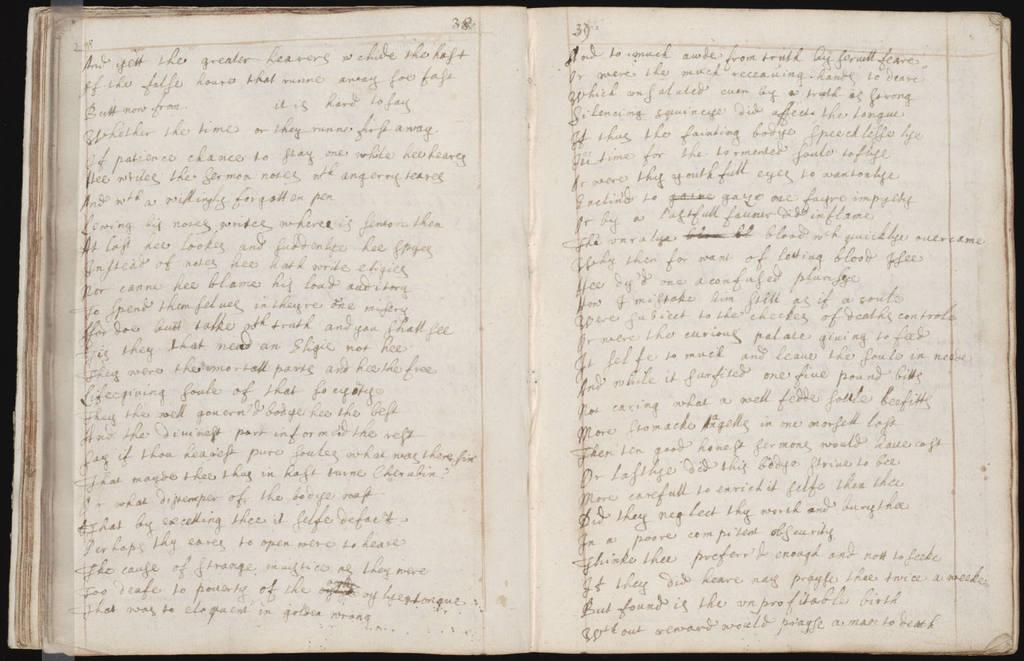<image>
Present a compact description of the photo's key features. A lined notebook has hand written passages with the number 38 on the pages. 